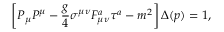<formula> <loc_0><loc_0><loc_500><loc_500>\left [ P _ { \mu } P ^ { \mu } - { \frac { g } { 4 } } \sigma ^ { \mu \nu } F _ { \mu \nu } ^ { a } \tau ^ { a } - m ^ { 2 } \right ] \Delta ( p ) = 1 ,</formula> 